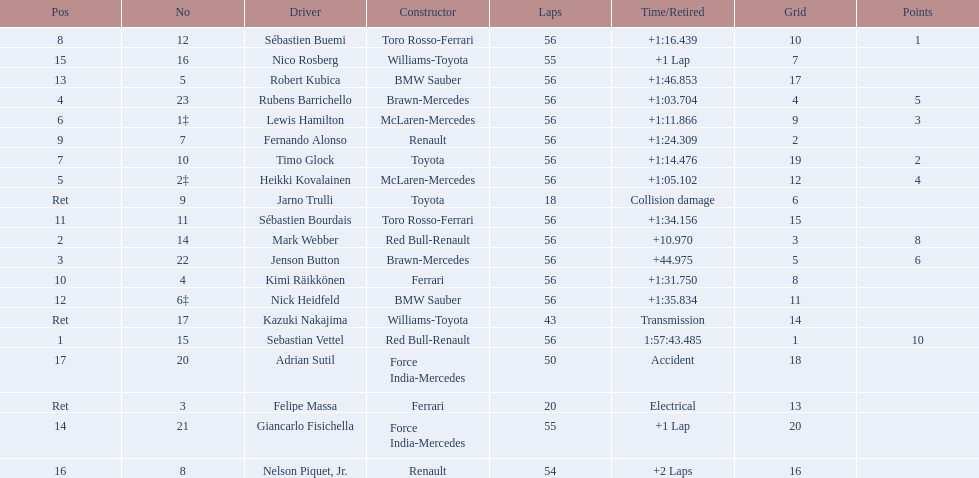What driver was last on the list? Jarno Trulli. 